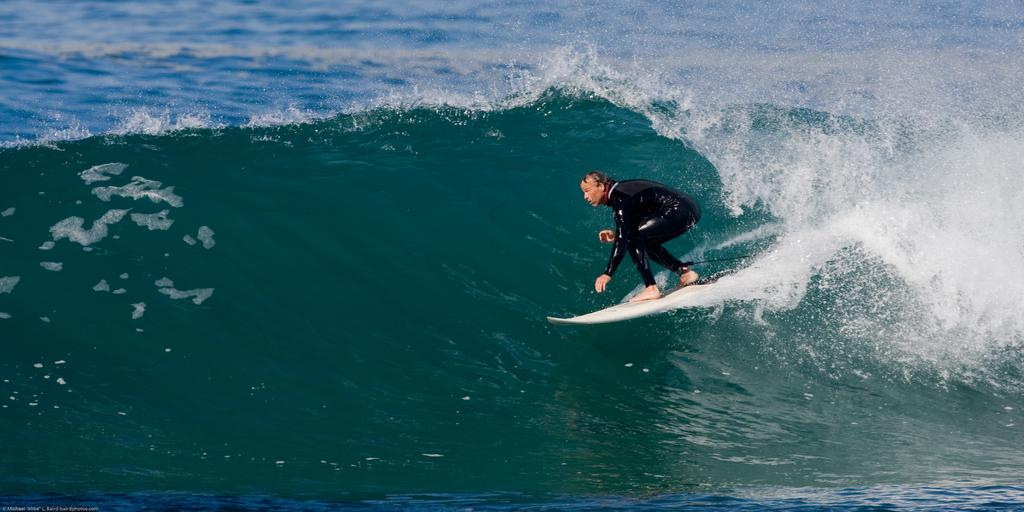Who is present in the image? There is a man in the image. What is the man wearing? The man is wearing a black dress. What activity is the man engaged in? The man is surfing on a board. Where is the board located? The board is on the water. What type of water can be seen in the image? The water appears to be in an ocean. What book is the man reading while surfing in the image? There is no book present in the image; the man is surfing on a board in the ocean. 